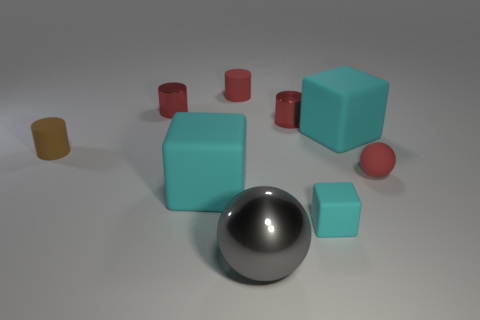What number of things are red things or objects that are to the right of the brown matte thing?
Your answer should be compact. 8. What color is the large metallic sphere?
Make the answer very short. Gray. The matte cylinder that is behind the brown cylinder is what color?
Your answer should be compact. Red. There is a cyan thing that is behind the tiny brown rubber object; what number of brown rubber objects are to the left of it?
Provide a short and direct response. 1. Is the size of the brown thing the same as the cyan matte cube behind the small matte sphere?
Give a very brief answer. No. Is there a rubber cylinder that has the same size as the gray ball?
Your answer should be very brief. No. How many objects are small yellow cubes or big cyan cubes?
Offer a terse response. 2. There is a red shiny object that is right of the red rubber cylinder; is its size the same as the sphere in front of the tiny matte sphere?
Make the answer very short. No. Are there any matte things that have the same shape as the large gray shiny thing?
Your answer should be compact. Yes. Are there fewer cyan objects that are to the right of the gray metal thing than cyan matte blocks?
Your response must be concise. Yes. 